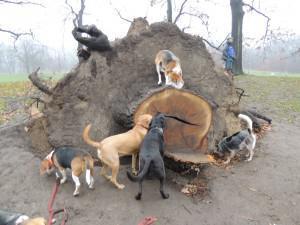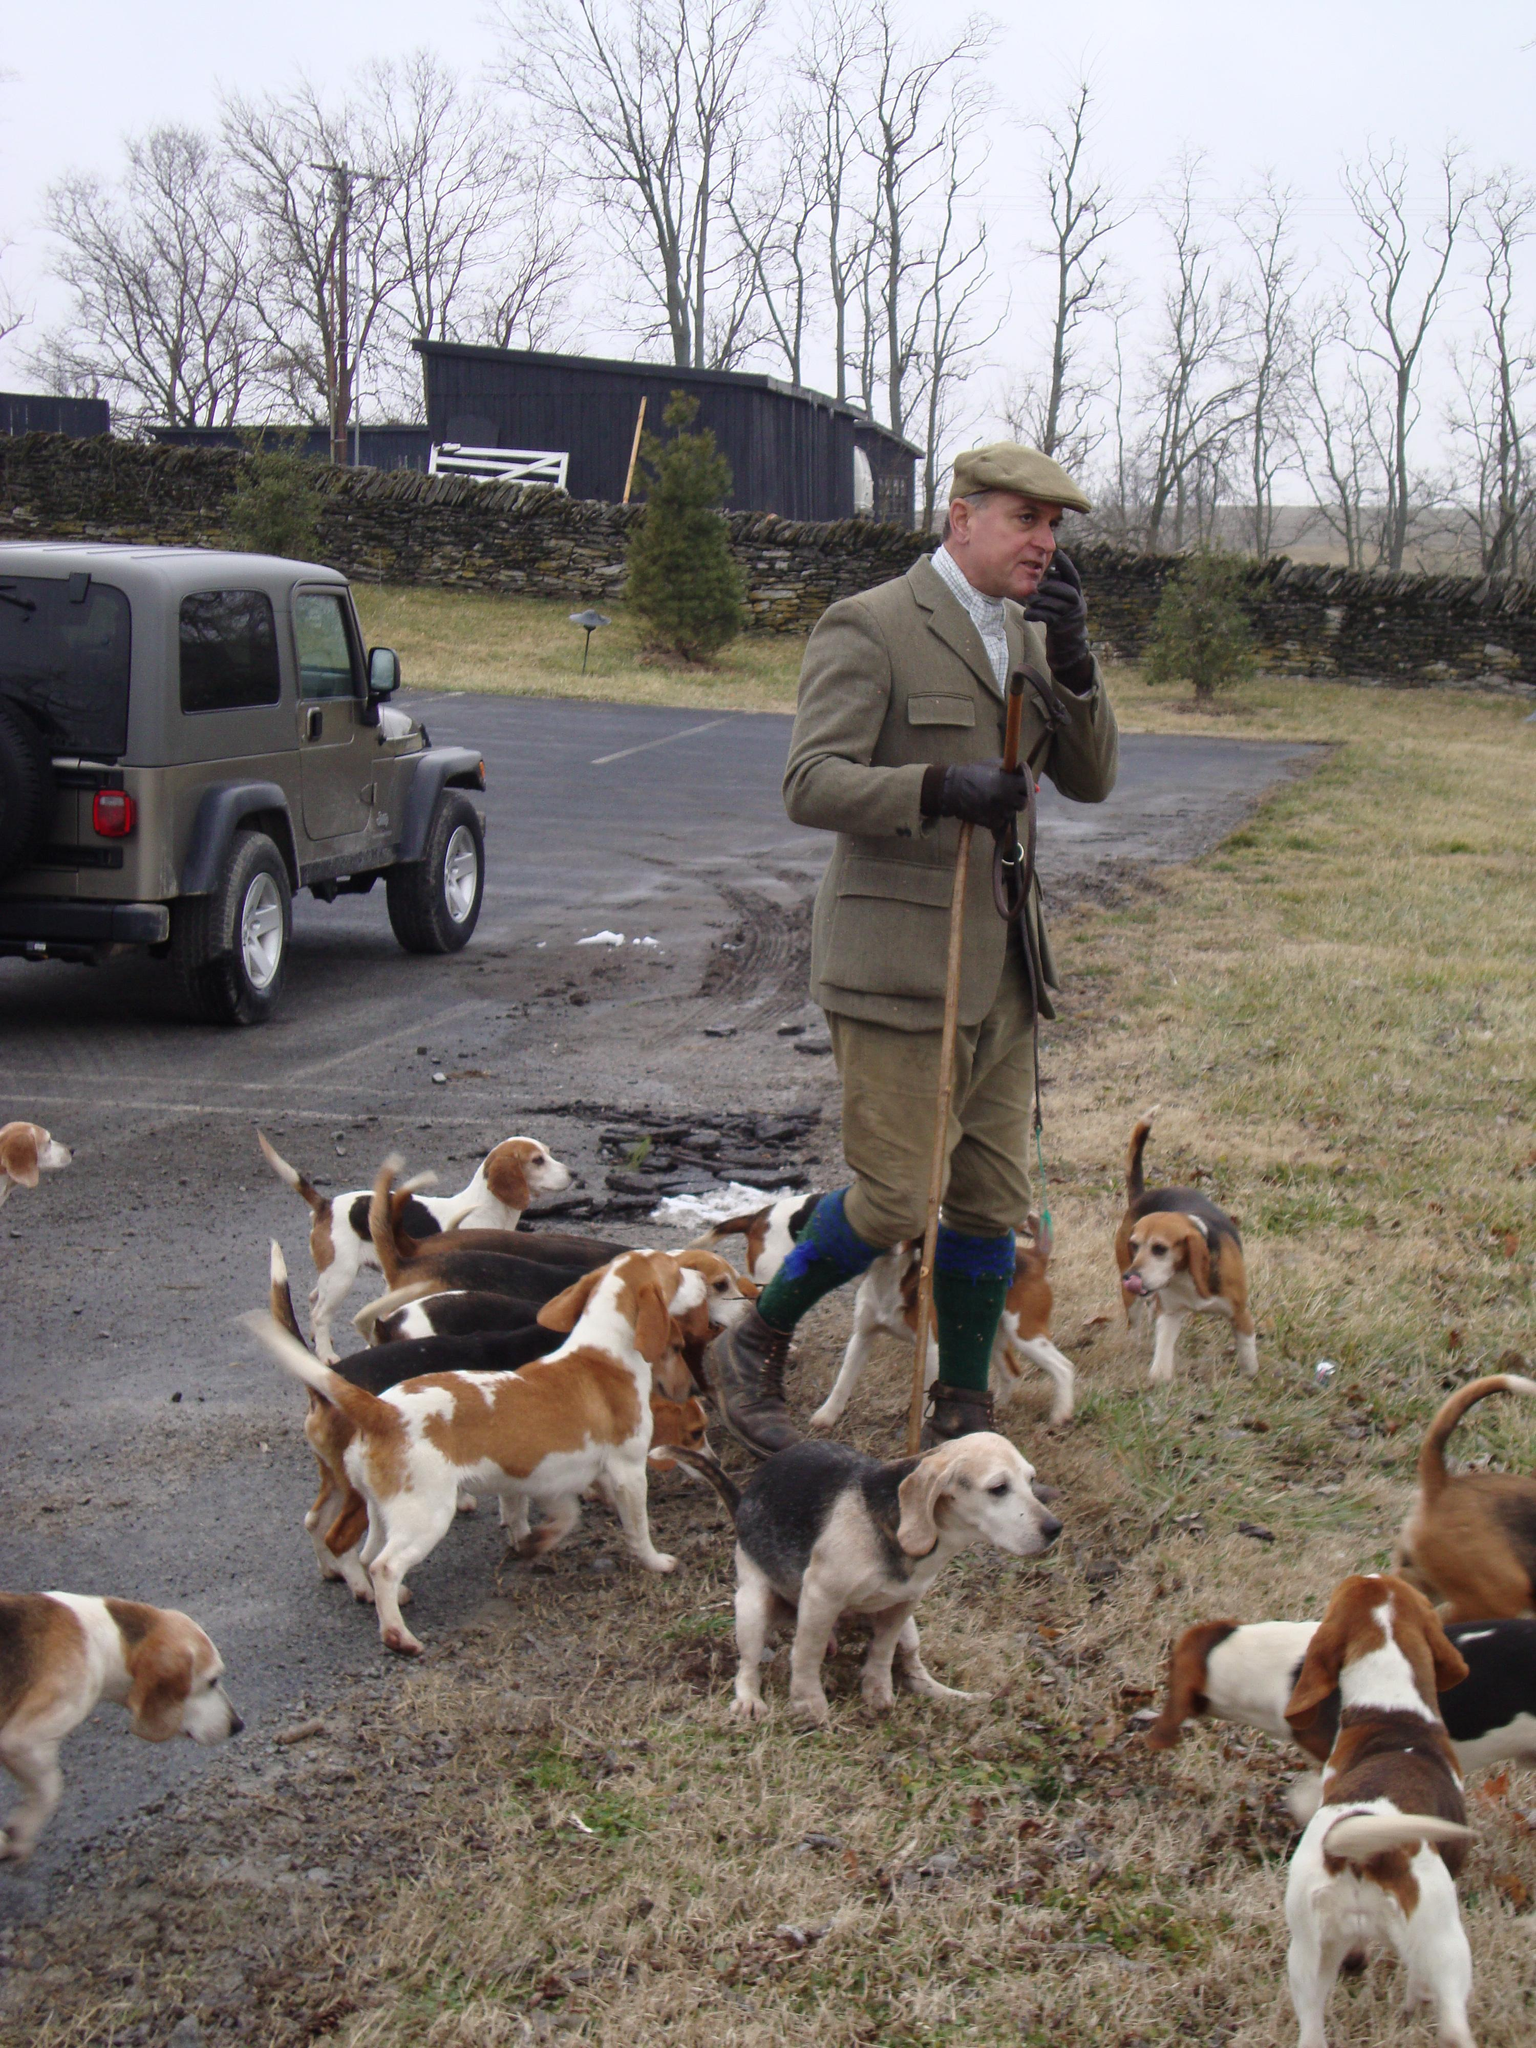The first image is the image on the left, the second image is the image on the right. Examine the images to the left and right. Is the description "Right image shows at least one man in white breeches with a pack of hounds." accurate? Answer yes or no. No. The first image is the image on the left, the second image is the image on the right. Examine the images to the left and right. Is the description "There is a single vehicle shown in one of the images." accurate? Answer yes or no. Yes. 